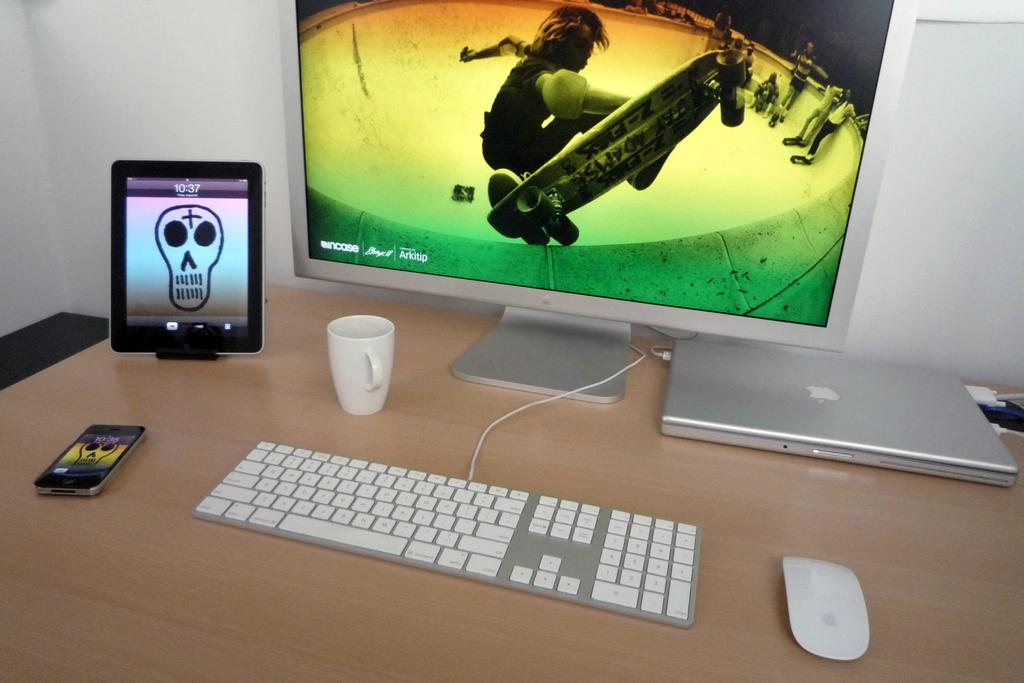Provide a one-sentence caption for the provided image. A computer desk with many electronics on it, one such being a tablet displaying the time as 10:37. 